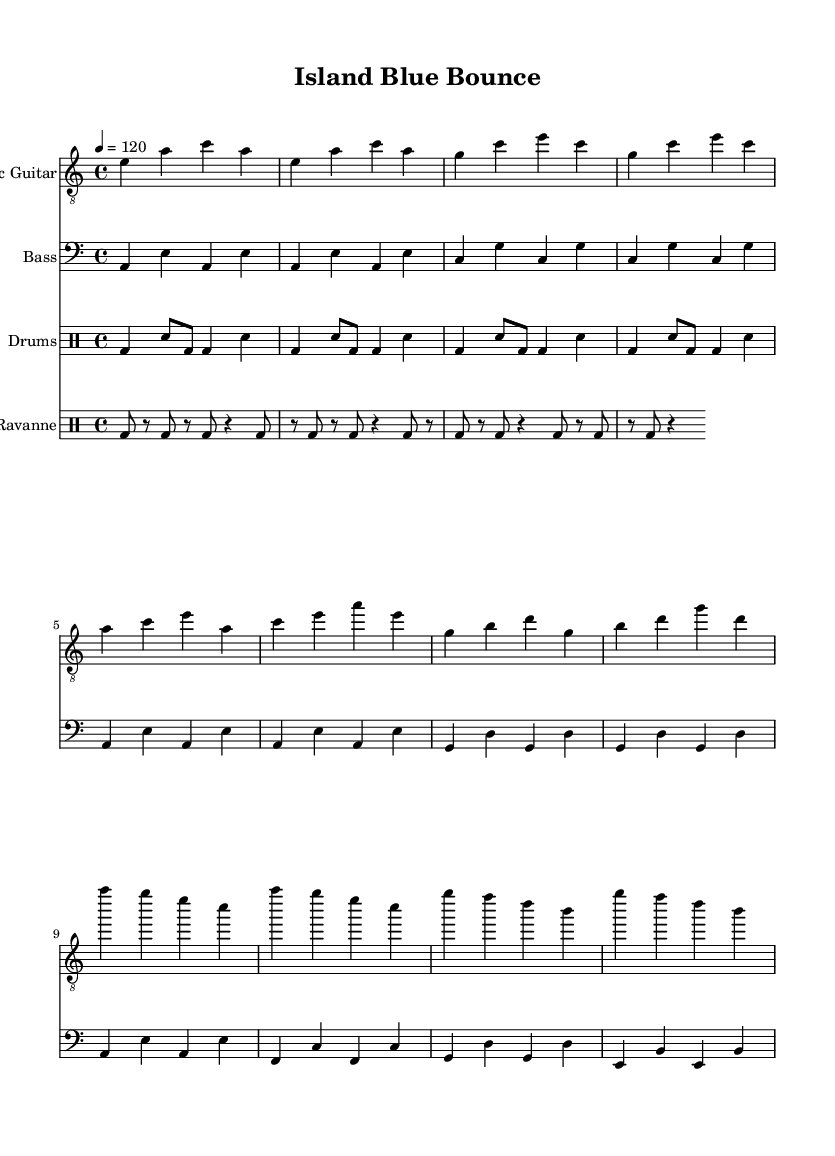What is the key signature of this music? The key signature is A minor, which has no sharps or flats. It can be determined by looking at the key signature indicated at the beginning of the sheet music.
Answer: A minor What is the time signature of this music? The time signature is 4/4, meaning there are four beats per measure and the quarter note receives one beat. This can be identified from the notation shown at the beginning of the piece.
Answer: 4/4 What is the tempo indicated in the music? The tempo is set at 120 beats per minute, indicated by the tempo marking in the score. This tells the performer how fast the music should be played.
Answer: 120 How many measures are in the chorus section? The chorus section contains four measures, which can be counted by identifying the groupings of notes after the verse in the sheet music. Each line in the chorus section contains one measure.
Answer: 4 What rhythmic pattern is used in the drums? The drums have a blues shuffle pattern as indicated in the drum part. This refers to the specific rhythmic structure that defines the blues feel, which can be observed in the drumming notation provided.
Answer: Shuffle pattern What is the primary instrument for the melodic line? The electric guitar is the primary instrument for the melodic line, as it carries the main melody throughout the piece. This can be identified by the presence of the melodic notation specifically for electric guitar in the score.
Answer: Electric guitar What unique rhythmic element is included in the percussion? The ravanne part features a 3-3-2 rhythmic pattern, which is a traditional Mauritian drumming style. This can be identified through the specific drum notation that outlines this pattern within the sheet music.
Answer: 3-3-2 pattern 